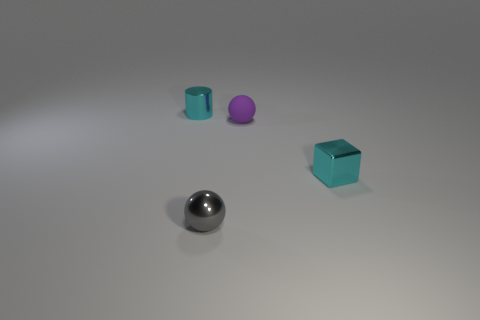Add 1 cubes. How many objects exist? 5 Subtract all cylinders. How many objects are left? 3 Subtract all cyan cylinders. Subtract all shiny objects. How many objects are left? 0 Add 3 cyan metal things. How many cyan metal things are left? 5 Add 2 tiny gray metal things. How many tiny gray metal things exist? 3 Subtract 0 brown balls. How many objects are left? 4 